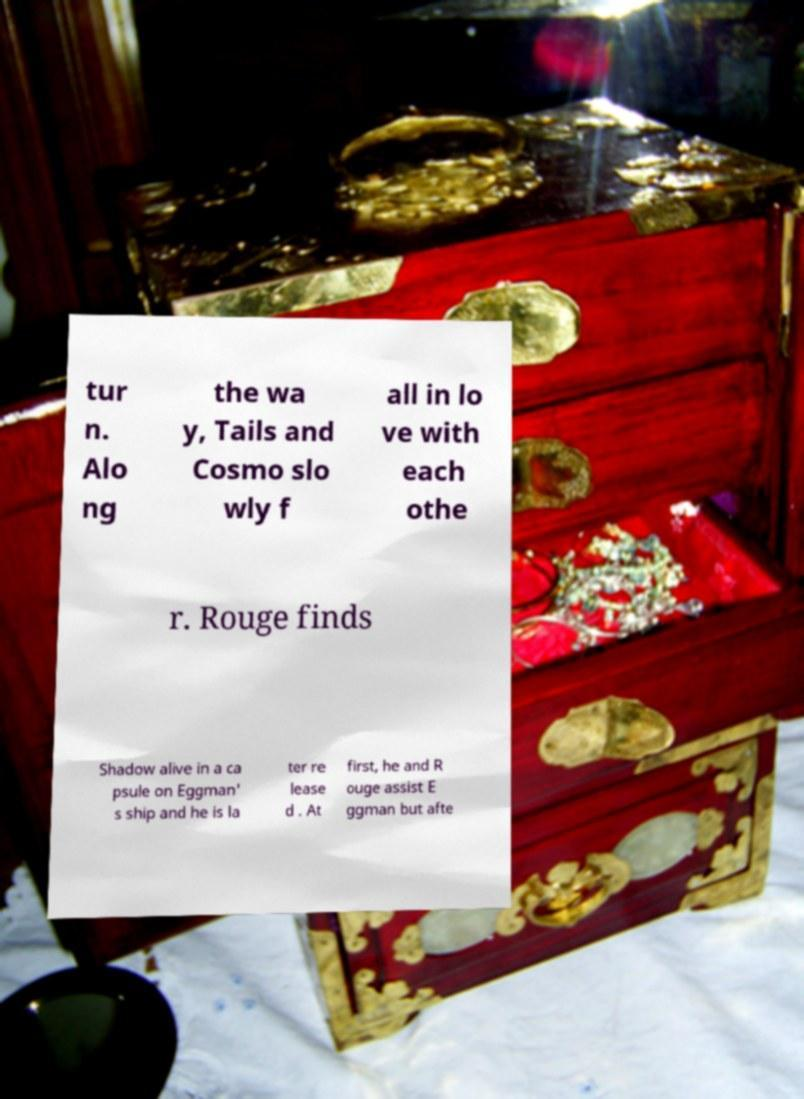Can you read and provide the text displayed in the image?This photo seems to have some interesting text. Can you extract and type it out for me? tur n. Alo ng the wa y, Tails and Cosmo slo wly f all in lo ve with each othe r. Rouge finds Shadow alive in a ca psule on Eggman' s ship and he is la ter re lease d . At first, he and R ouge assist E ggman but afte 